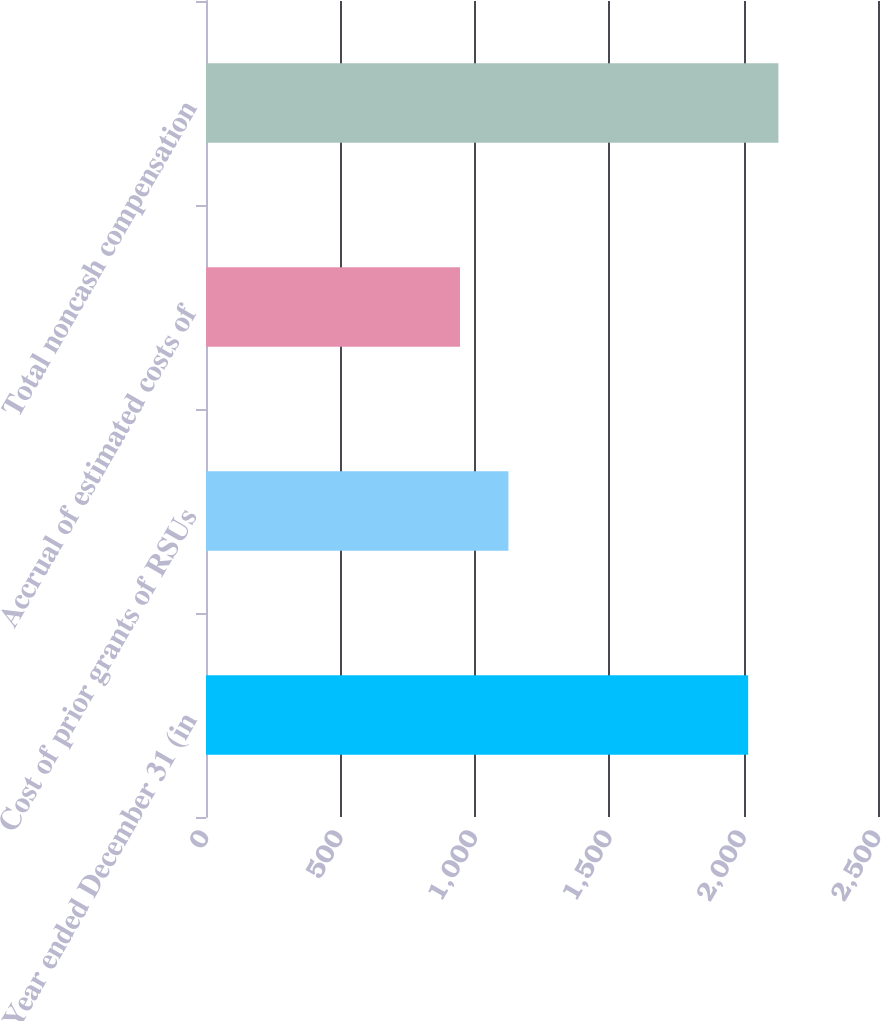<chart> <loc_0><loc_0><loc_500><loc_500><bar_chart><fcel>Year ended December 31 (in<fcel>Cost of prior grants of RSUs<fcel>Accrual of estimated costs of<fcel>Total noncash compensation<nl><fcel>2017<fcel>1125<fcel>945<fcel>2129.5<nl></chart> 